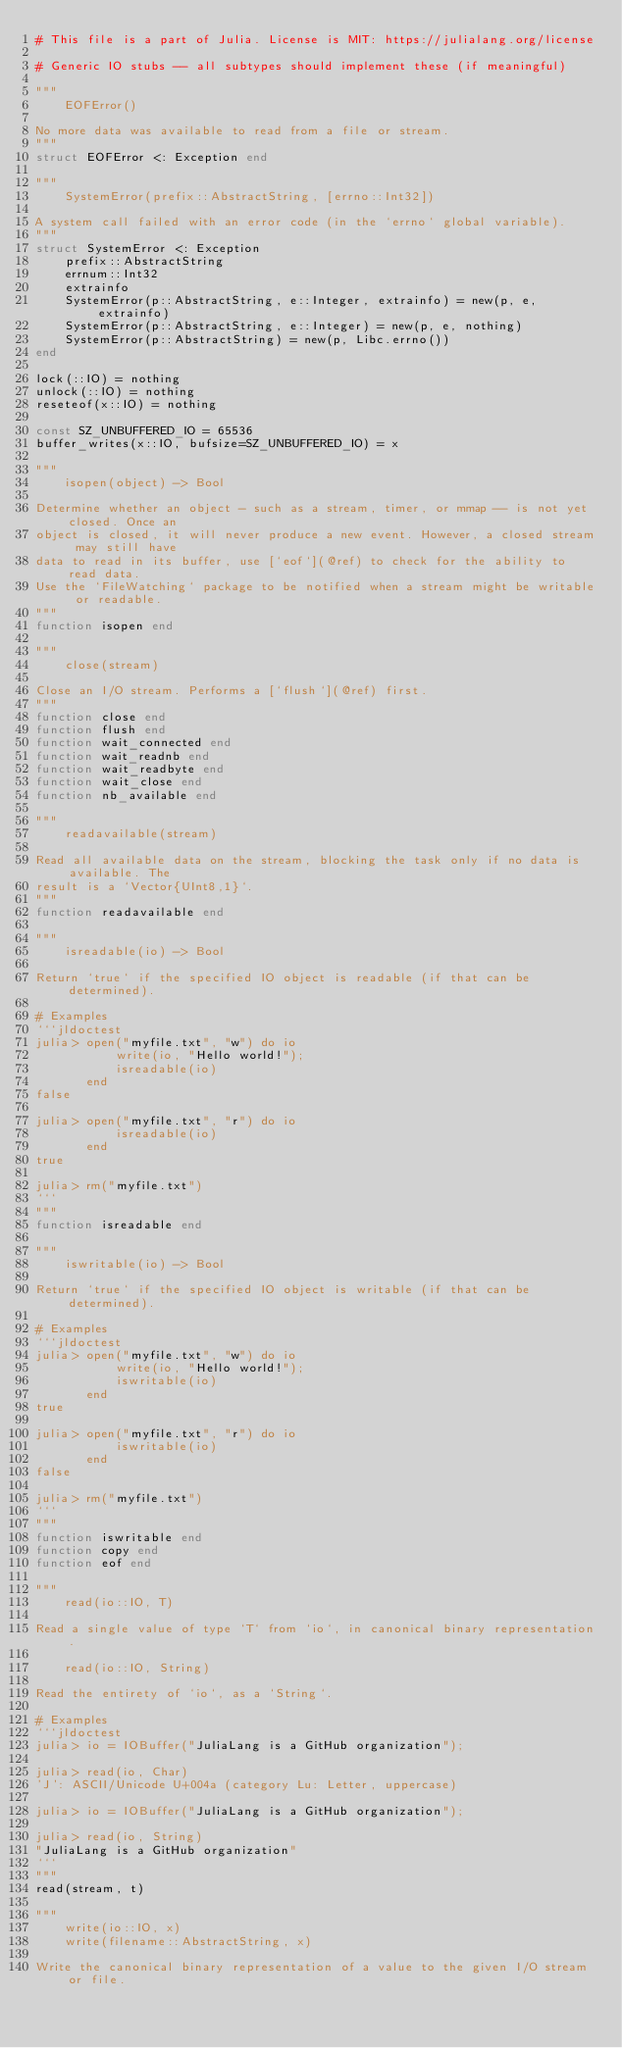Convert code to text. <code><loc_0><loc_0><loc_500><loc_500><_Julia_># This file is a part of Julia. License is MIT: https://julialang.org/license

# Generic IO stubs -- all subtypes should implement these (if meaningful)

"""
    EOFError()

No more data was available to read from a file or stream.
"""
struct EOFError <: Exception end

"""
    SystemError(prefix::AbstractString, [errno::Int32])

A system call failed with an error code (in the `errno` global variable).
"""
struct SystemError <: Exception
    prefix::AbstractString
    errnum::Int32
    extrainfo
    SystemError(p::AbstractString, e::Integer, extrainfo) = new(p, e, extrainfo)
    SystemError(p::AbstractString, e::Integer) = new(p, e, nothing)
    SystemError(p::AbstractString) = new(p, Libc.errno())
end

lock(::IO) = nothing
unlock(::IO) = nothing
reseteof(x::IO) = nothing

const SZ_UNBUFFERED_IO = 65536
buffer_writes(x::IO, bufsize=SZ_UNBUFFERED_IO) = x

"""
    isopen(object) -> Bool

Determine whether an object - such as a stream, timer, or mmap -- is not yet closed. Once an
object is closed, it will never produce a new event. However, a closed stream may still have
data to read in its buffer, use [`eof`](@ref) to check for the ability to read data.
Use the `FileWatching` package to be notified when a stream might be writable or readable.
"""
function isopen end

"""
    close(stream)

Close an I/O stream. Performs a [`flush`](@ref) first.
"""
function close end
function flush end
function wait_connected end
function wait_readnb end
function wait_readbyte end
function wait_close end
function nb_available end

"""
    readavailable(stream)

Read all available data on the stream, blocking the task only if no data is available. The
result is a `Vector{UInt8,1}`.
"""
function readavailable end

"""
    isreadable(io) -> Bool

Return `true` if the specified IO object is readable (if that can be determined).

# Examples
```jldoctest
julia> open("myfile.txt", "w") do io
           write(io, "Hello world!");
           isreadable(io)
       end
false

julia> open("myfile.txt", "r") do io
           isreadable(io)
       end
true

julia> rm("myfile.txt")
```
"""
function isreadable end

"""
    iswritable(io) -> Bool

Return `true` if the specified IO object is writable (if that can be determined).

# Examples
```jldoctest
julia> open("myfile.txt", "w") do io
           write(io, "Hello world!");
           iswritable(io)
       end
true

julia> open("myfile.txt", "r") do io
           iswritable(io)
       end
false

julia> rm("myfile.txt")
```
"""
function iswritable end
function copy end
function eof end

"""
    read(io::IO, T)

Read a single value of type `T` from `io`, in canonical binary representation.

    read(io::IO, String)

Read the entirety of `io`, as a `String`.

# Examples
```jldoctest
julia> io = IOBuffer("JuliaLang is a GitHub organization");

julia> read(io, Char)
'J': ASCII/Unicode U+004a (category Lu: Letter, uppercase)

julia> io = IOBuffer("JuliaLang is a GitHub organization");

julia> read(io, String)
"JuliaLang is a GitHub organization"
```
"""
read(stream, t)

"""
    write(io::IO, x)
    write(filename::AbstractString, x)

Write the canonical binary representation of a value to the given I/O stream or file.</code> 